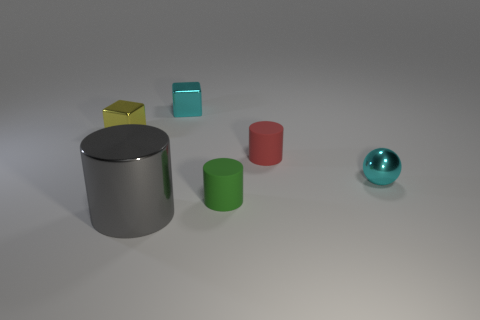Add 2 small matte cylinders. How many objects exist? 8 Subtract all cubes. How many objects are left? 4 Subtract all blocks. Subtract all cyan cubes. How many objects are left? 3 Add 1 cyan metal spheres. How many cyan metal spheres are left? 2 Add 6 yellow objects. How many yellow objects exist? 7 Subtract 1 red cylinders. How many objects are left? 5 